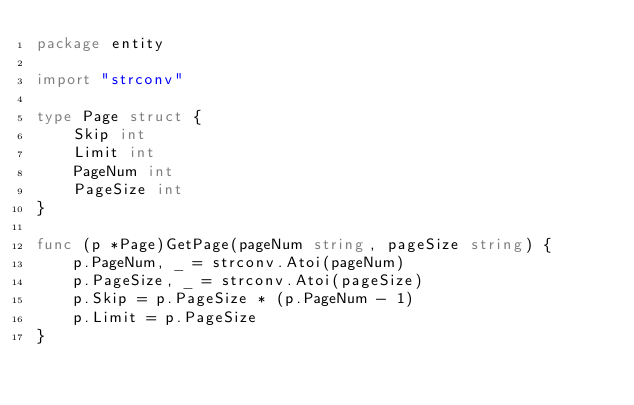<code> <loc_0><loc_0><loc_500><loc_500><_Go_>package entity

import "strconv"

type Page struct {
	Skip int
	Limit int
	PageNum int
	PageSize int
}

func (p *Page)GetPage(pageNum string, pageSize string) {
	p.PageNum, _ = strconv.Atoi(pageNum)
	p.PageSize, _ = strconv.Atoi(pageSize)
	p.Skip = p.PageSize * (p.PageNum - 1)
	p.Limit = p.PageSize
}</code> 